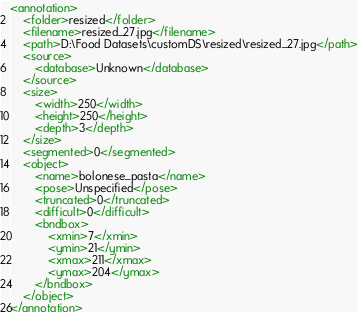Convert code to text. <code><loc_0><loc_0><loc_500><loc_500><_XML_><annotation>
	<folder>resized</folder>
	<filename>resized_27.jpg</filename>
	<path>D:\Food Datasets\customDS\resized\resized_27.jpg</path>
	<source>
		<database>Unknown</database>
	</source>
	<size>
		<width>250</width>
		<height>250</height>
		<depth>3</depth>
	</size>
	<segmented>0</segmented>
	<object>
		<name>bolonese_pasta</name>
		<pose>Unspecified</pose>
		<truncated>0</truncated>
		<difficult>0</difficult>
		<bndbox>
			<xmin>7</xmin>
			<ymin>21</ymin>
			<xmax>211</xmax>
			<ymax>204</ymax>
		</bndbox>
	</object>
</annotation>
</code> 